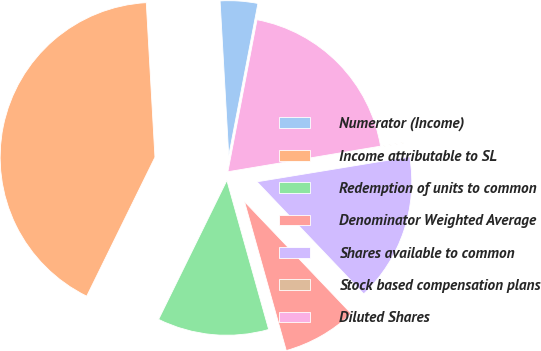<chart> <loc_0><loc_0><loc_500><loc_500><pie_chart><fcel>Numerator (Income)<fcel>Income attributable to SL<fcel>Redemption of units to common<fcel>Denominator Weighted Average<fcel>Shares available to common<fcel>Stock based compensation plans<fcel>Diluted Shares<nl><fcel>3.91%<fcel>41.84%<fcel>11.62%<fcel>7.76%<fcel>15.48%<fcel>0.05%<fcel>19.34%<nl></chart> 